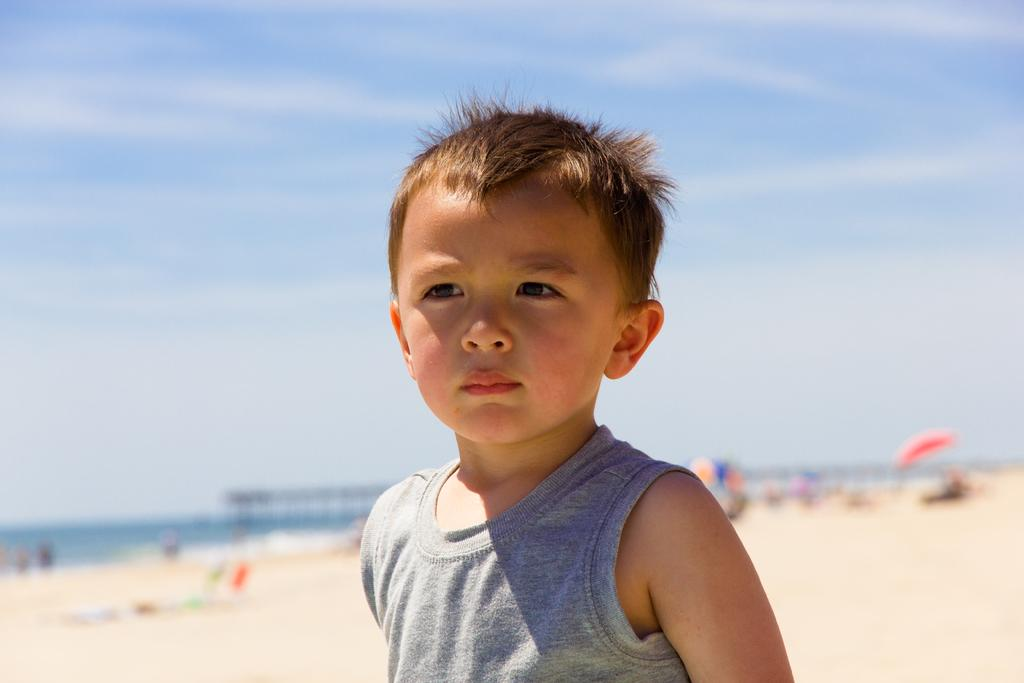What is the main subject of the image? There is a boy standing in the middle of the image. What can be seen in the background of the image? There are clouds and the sky visible in the background of the image. How is the background of the image depicted? The background of the image is blurred. What color is the crayon being used by the boy in the image? There is no crayon present in the image; the boy is standing and not using any drawing tools. 